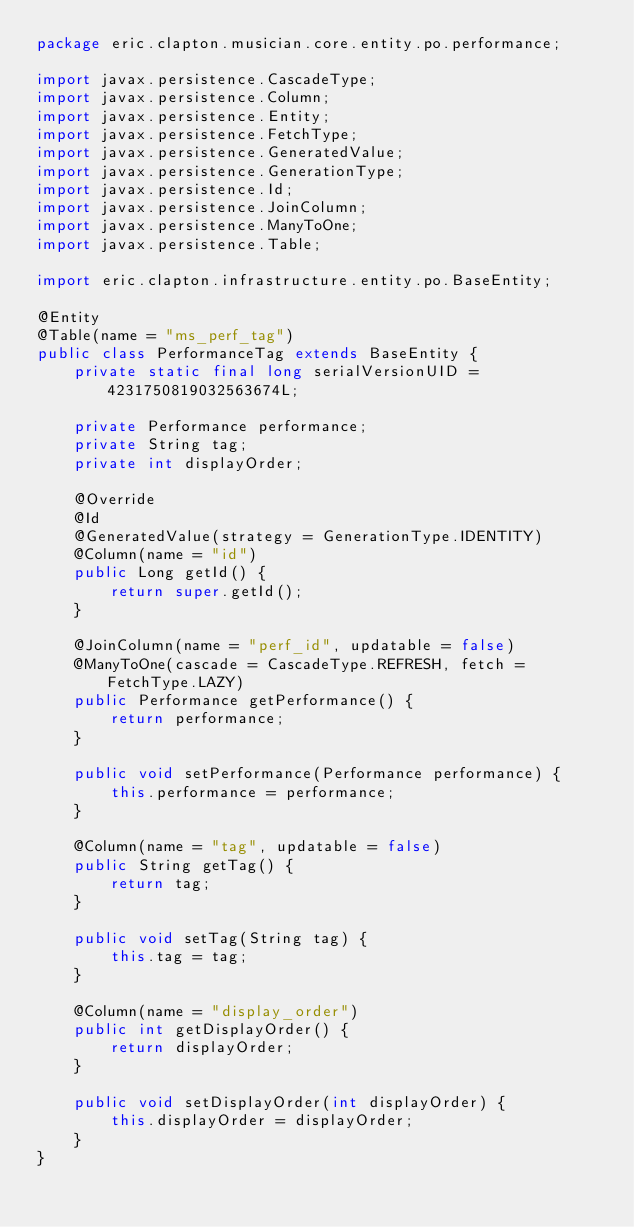<code> <loc_0><loc_0><loc_500><loc_500><_Java_>package eric.clapton.musician.core.entity.po.performance;

import javax.persistence.CascadeType;
import javax.persistence.Column;
import javax.persistence.Entity;
import javax.persistence.FetchType;
import javax.persistence.GeneratedValue;
import javax.persistence.GenerationType;
import javax.persistence.Id;
import javax.persistence.JoinColumn;
import javax.persistence.ManyToOne;
import javax.persistence.Table;

import eric.clapton.infrastructure.entity.po.BaseEntity;

@Entity
@Table(name = "ms_perf_tag")
public class PerformanceTag extends BaseEntity {
	private static final long serialVersionUID = 4231750819032563674L;

	private Performance performance;
	private String tag;
	private int displayOrder;

	@Override
	@Id
	@GeneratedValue(strategy = GenerationType.IDENTITY)
	@Column(name = "id")
	public Long getId() {
		return super.getId();
	}

	@JoinColumn(name = "perf_id", updatable = false)
	@ManyToOne(cascade = CascadeType.REFRESH, fetch = FetchType.LAZY)
	public Performance getPerformance() {
		return performance;
	}

	public void setPerformance(Performance performance) {
		this.performance = performance;
	}

	@Column(name = "tag", updatable = false)
	public String getTag() {
		return tag;
	}

	public void setTag(String tag) {
		this.tag = tag;
	}

	@Column(name = "display_order")
	public int getDisplayOrder() {
		return displayOrder;
	}

	public void setDisplayOrder(int displayOrder) {
		this.displayOrder = displayOrder;
	}
}
</code> 